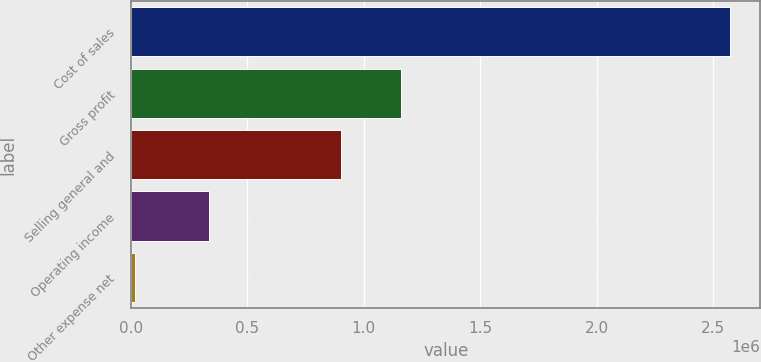Convert chart. <chart><loc_0><loc_0><loc_500><loc_500><bar_chart><fcel>Cost of sales<fcel>Gross profit<fcel>Selling general and<fcel>Operating income<fcel>Other expense net<nl><fcel>2.57545e+06<fcel>1.1598e+06<fcel>903864<fcel>335422<fcel>16114<nl></chart> 